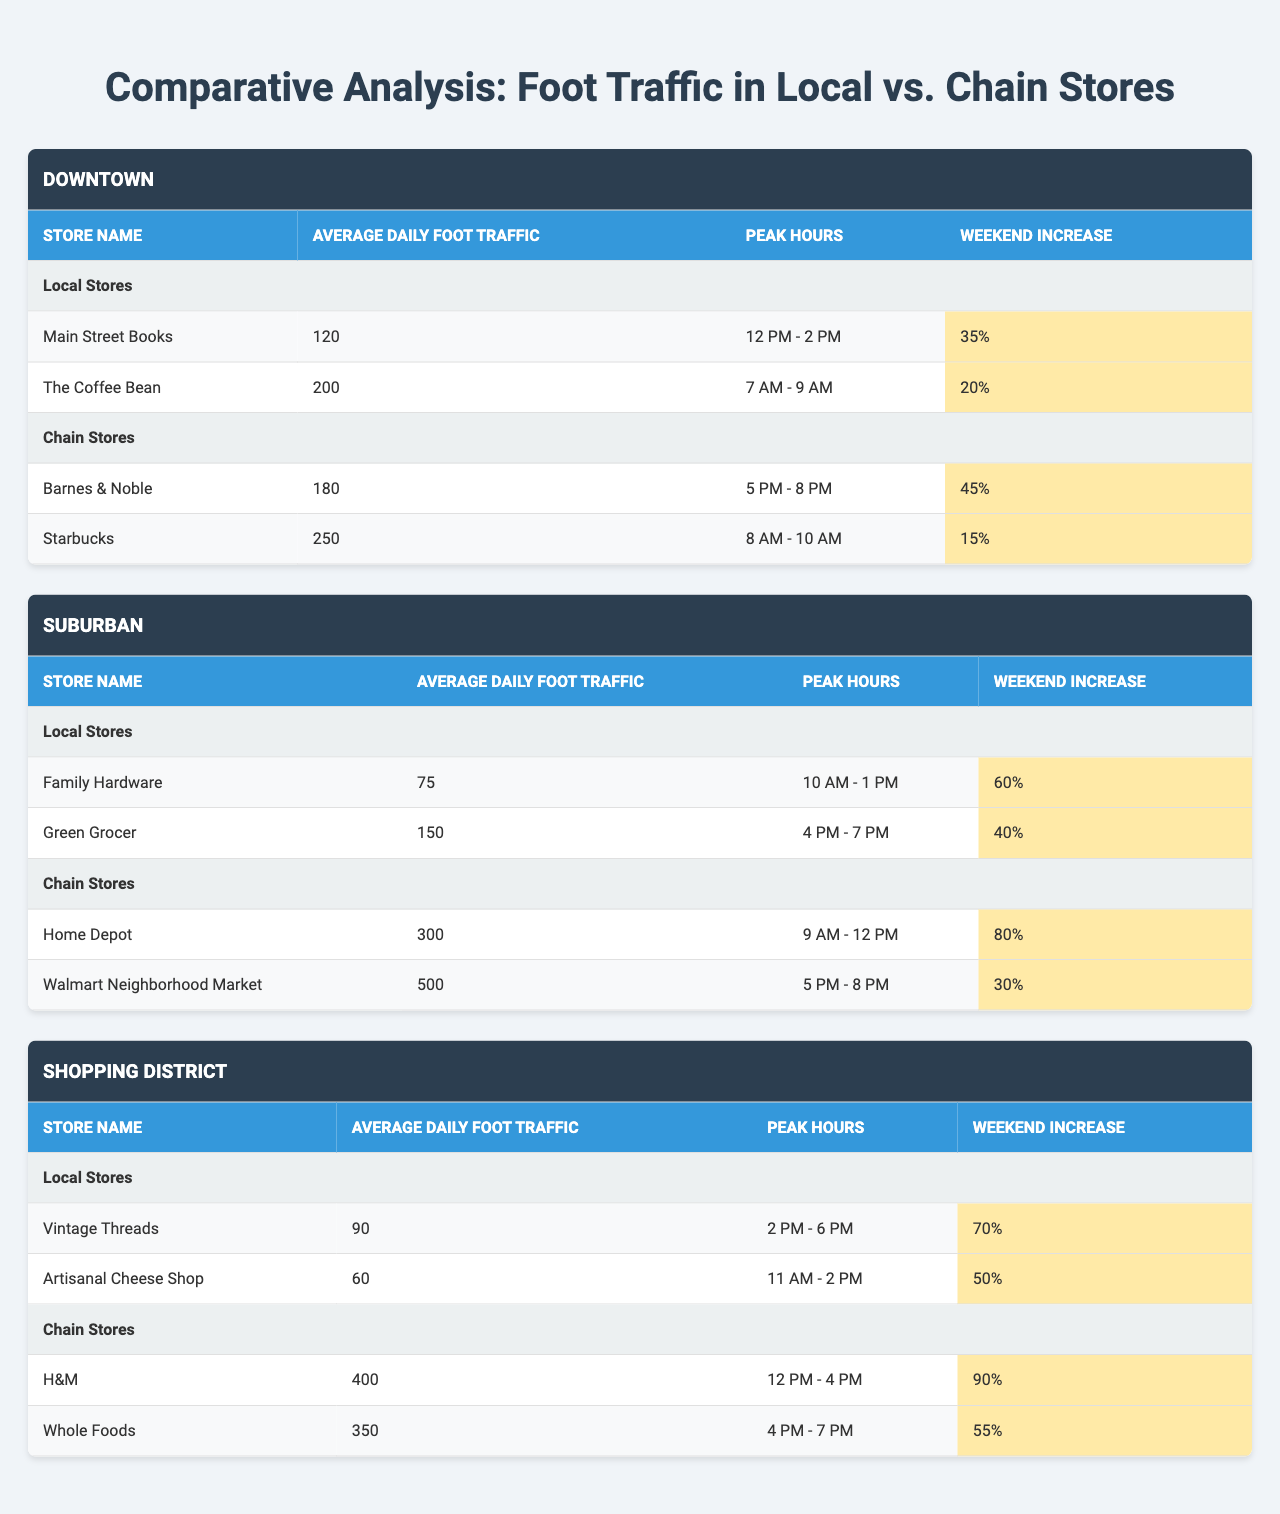What is the average daily foot traffic of "Main Street Books"? The table lists "Main Street Books" under local stores in the Downtown neighborhood with an average daily foot traffic of 120.
Answer: 120 What are the peak hours for "Barnes & Noble"? According to the table, "Barnes & Noble" is a chain store in the Downtown neighborhood and has peak hours from 5 PM to 8 PM.
Answer: 5 PM - 8 PM How much higher is the average daily foot traffic of "Walmart Neighborhood Market" compared to "Family Hardware"? "Walmart Neighborhood Market" has an average daily foot traffic of 500 while "Family Hardware" has 75. The difference is 500 - 75 = 425.
Answer: 425 Which neighborhood has the highest foot traffic for local stores? In the Downtown neighborhood, the combined foot traffic for local stores is 120 (Main Street Books) + 200 (The Coffee Bean) = 320. In the Suburban neighborhood, it's 75 (Family Hardware) + 150 (Green Grocer) = 225. In the Shopping District, it’s 90 (Vintage Threads) + 60 (Artisanal Cheese Shop) = 150. Therefore, Downtown has the highest foot traffic.
Answer: Downtown What percentage increase does "H&M" have on weekends compared to its average daily foot traffic? The weekend increase for "H&M" is 90%. To find the increase in numbers, we calculate 90% of its average daily foot traffic of 400, which is 0.90 * 400 = 360. This means the foot traffic including the weekend increase is 400 + 360 = 760, and so the percent increase itself is already stated as 90%. Therefore, the answer is simply the percentage increase mentioned.
Answer: 90% Did any local store have a greater average daily foot traffic than the chain store "Home Depot"? The average daily foot traffic for "Home Depot" is 300, while the highest local store, "The Coffee Bean," has 200. Thus, no local store exceeded 300 in average daily foot traffic.
Answer: No Which local store in the Shopping District has the highest weekend foot traffic increase? "Artisanal Cheese Shop" has a weekend increase of 50%, while "Vintage Threads" has 70%. Thus, Vintage Threads has the highest weekend increase of foot traffic among local stores.
Answer: Vintage Threads What is the total average daily foot traffic for all chain stores in the Suburban area? The average daily foot traffic for chain stores in the Suburban area is 300 (Home Depot) + 500 (Walmart Neighborhood Market) = 800.
Answer: 800 How does the average daily foot traffic of local stores in the Downtown neighborhood compare with that in the Shopping District? The average daily foot traffic for local stores in Downtown is 320 (120 + 200), and in the Shopping District, it is 150 (90 + 60). The difference is 320 - 150 = 170. So, Downtown has a higher average.
Answer: 170 Is the average daily foot traffic for chain stores in the Downtown neighborhood higher than that in the Shopping District? The average daily foot traffic for chain stores in Downtown is 430 (180 + 250), while in the Shopping District it is 750 (400 + 350). 430 is less than 750.
Answer: No 